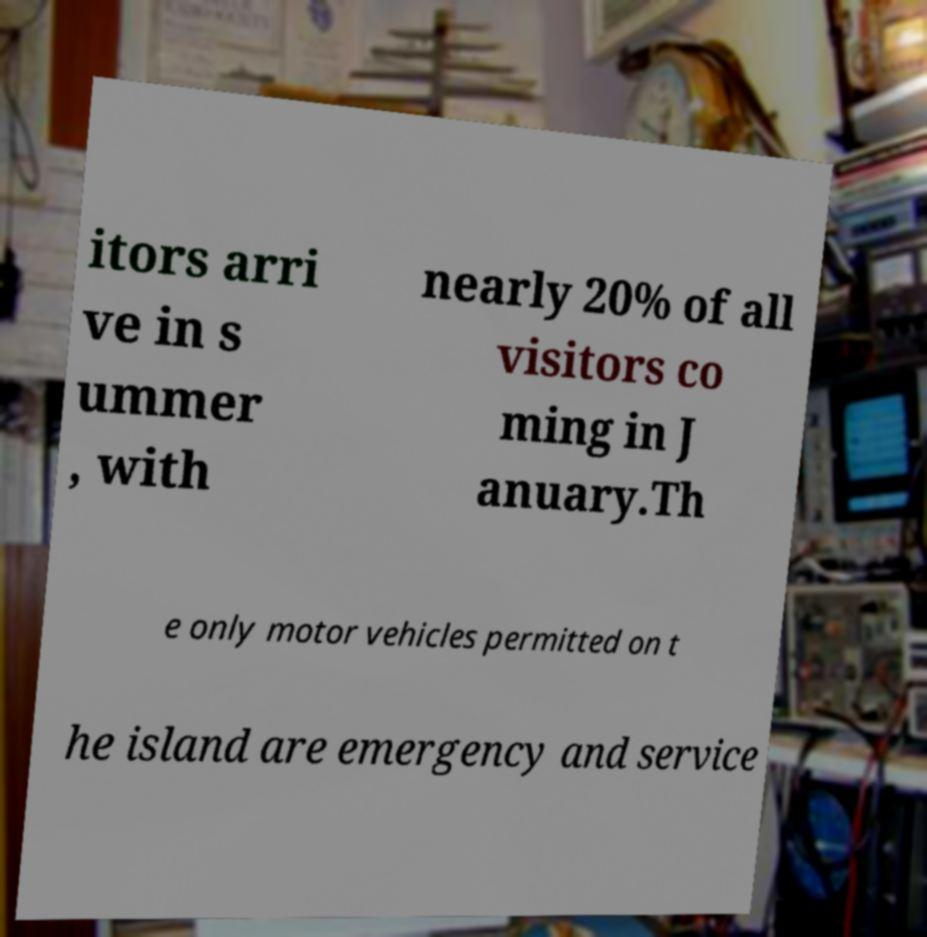For documentation purposes, I need the text within this image transcribed. Could you provide that? itors arri ve in s ummer , with nearly 20% of all visitors co ming in J anuary.Th e only motor vehicles permitted on t he island are emergency and service 